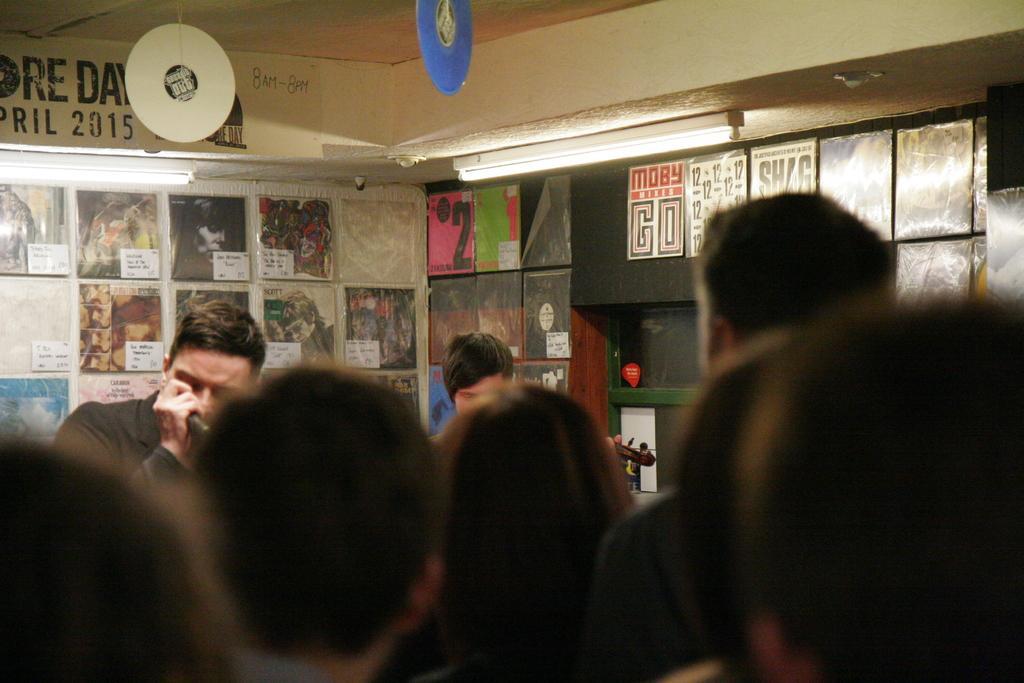In one or two sentences, can you explain what this image depicts? In this picture we can see many peoples were standing. On the left there is a man who is wearing black t-shirt and holding a mic. In the background we can see the posts, photo frames and other objects on the wall. At the top we can see some cotton papers were hanging from the roof. On the right there is a tube light. 